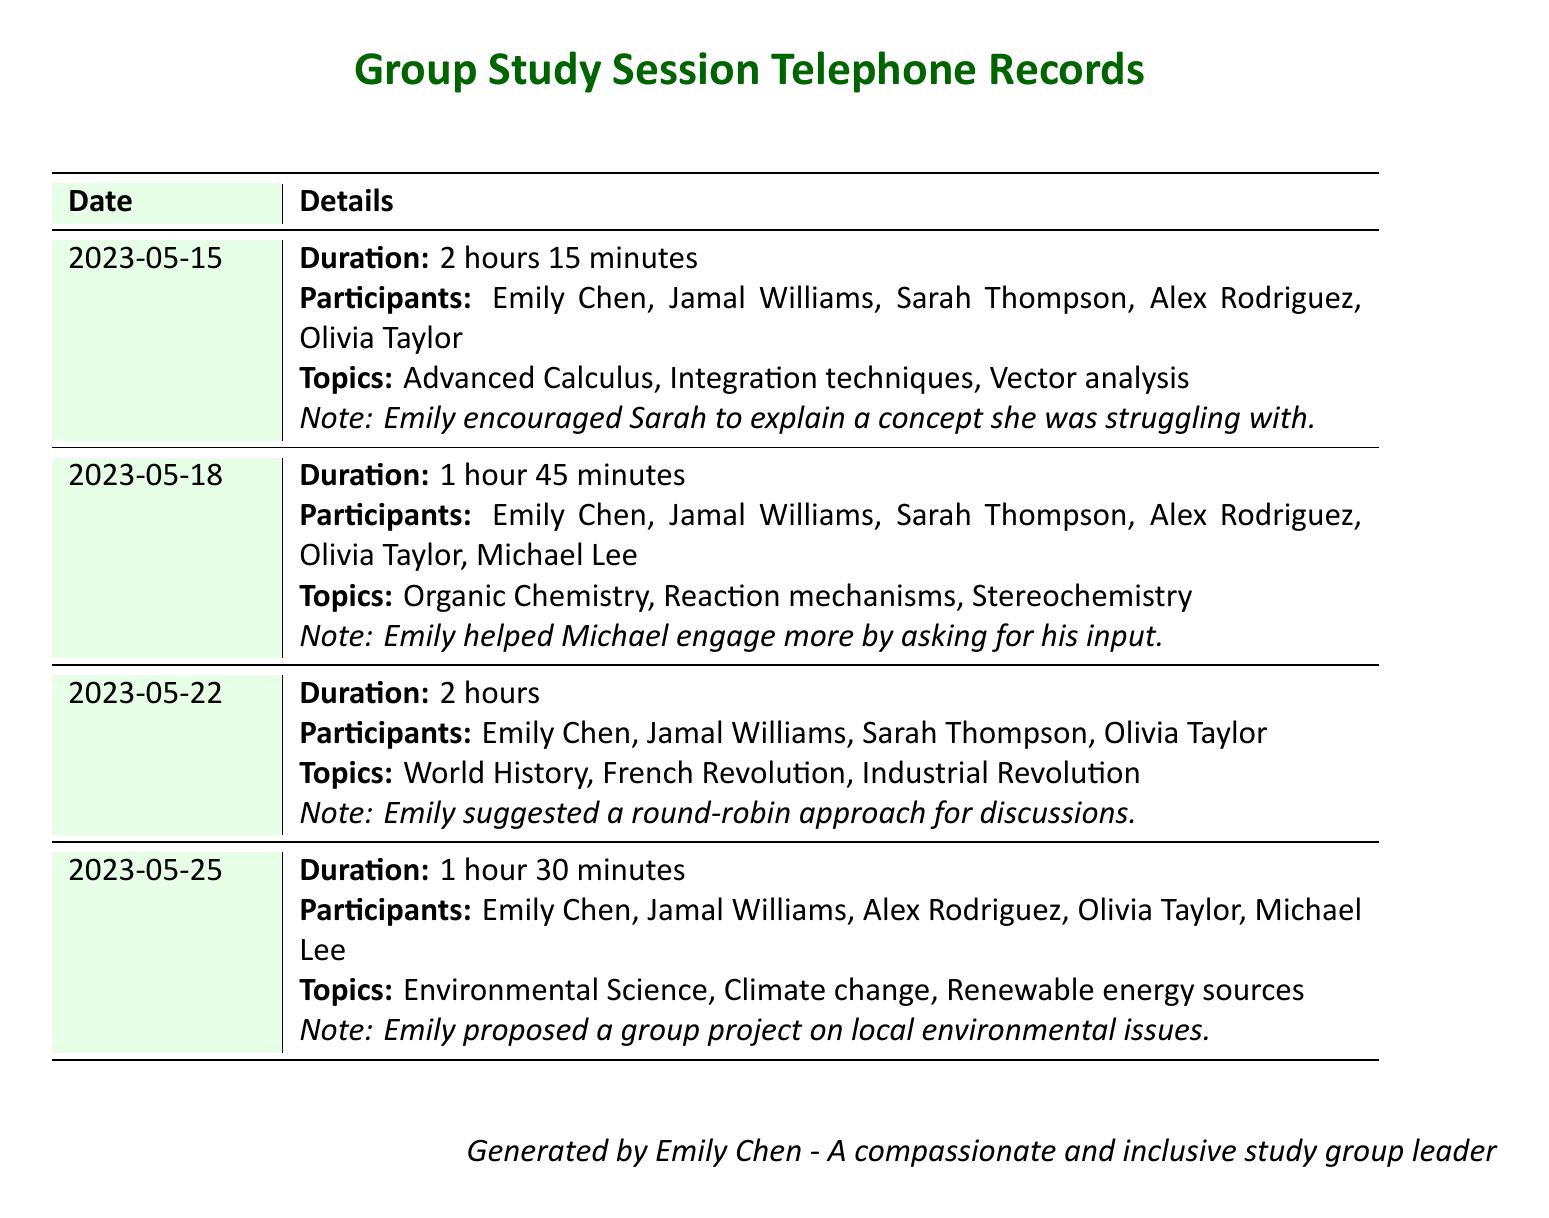What was the duration of the first study session? The duration is listed under the first entry in the document, which states 2 hours 15 minutes.
Answer: 2 hours 15 minutes Who was a participant in the study session on May 18? The participants for the session on May 18 are clearly listed in the corresponding entry, including names such as Michael Lee.
Answer: Michael Lee What topic was discussed during the session on May 22? The topics discussed on that date are outlined in the entry, including World History and related subjects.
Answer: World History How many participants were involved in the session on May 25? The number of participants can be counted from the entry for May 25, which provides a total of five names.
Answer: 5 What approach did Emily suggest for discussions on May 22? This suggestion is documented in the notes for that session, mentioning a round-robin approach.
Answer: Round-robin approach Which topic was covered during the last session listed? The last session entry details the topics discussed, including Environmental Science.
Answer: Environmental Science What is a notable action Emily took during the May 18 session? The note mentions that Emily helped Michael engage more actively during this session.
Answer: Helped Michael engage What step did Emily propose in the May 25 study session? The document mentions an idea for a group project on local environmental issues that Emily proposed.
Answer: Group project on local environmental issues 